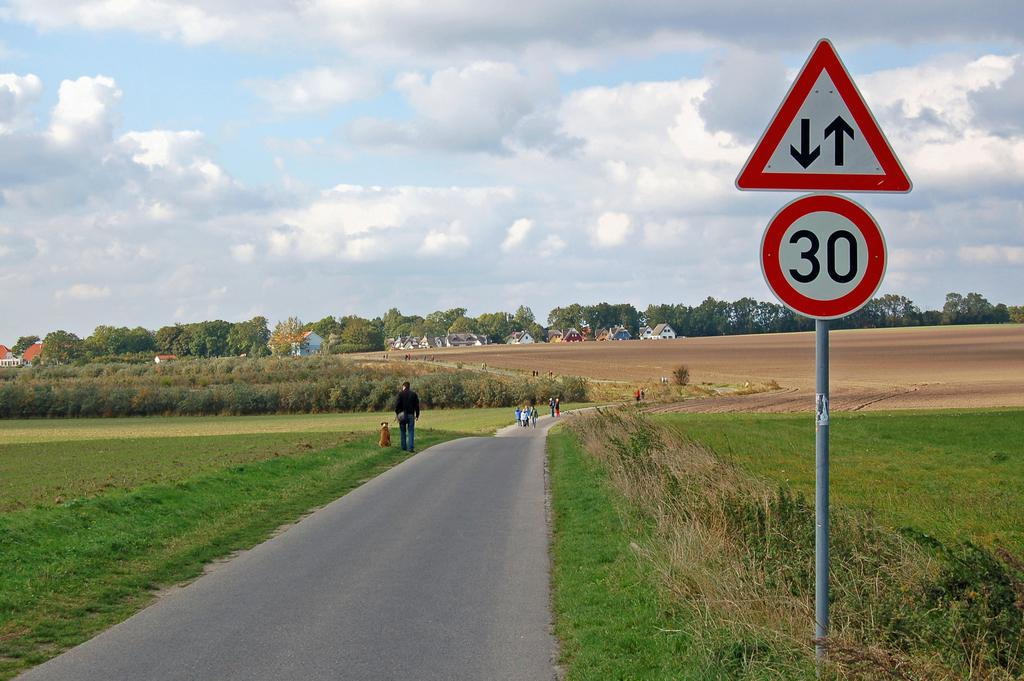Provide a one-sentence caption for the provided image. A sign to let car know that the speed limit is 30 and some people are walking at the back. 